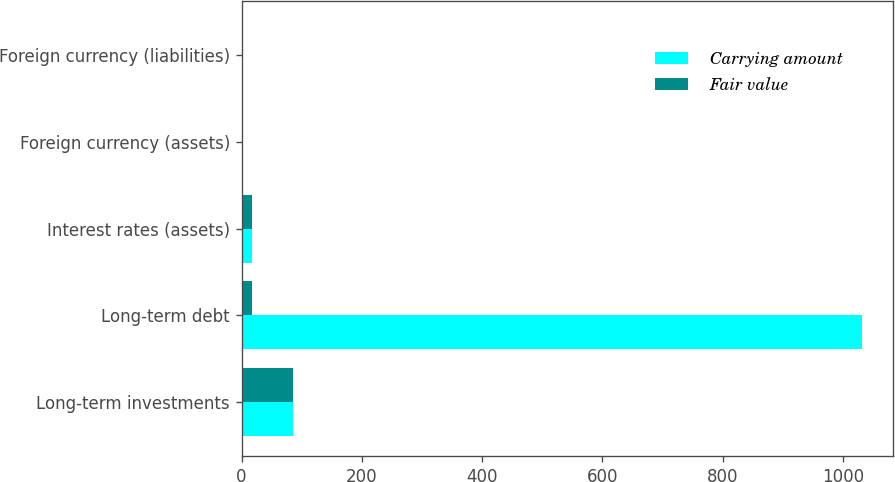Convert chart to OTSL. <chart><loc_0><loc_0><loc_500><loc_500><stacked_bar_chart><ecel><fcel>Long-term investments<fcel>Long-term debt<fcel>Interest rates (assets)<fcel>Foreign currency (assets)<fcel>Foreign currency (liabilities)<nl><fcel>Carrying amount<fcel>86.1<fcel>1031.5<fcel>16.7<fcel>0.9<fcel>1.9<nl><fcel>Fair value<fcel>86.1<fcel>16.7<fcel>16.7<fcel>0.9<fcel>1.9<nl></chart> 